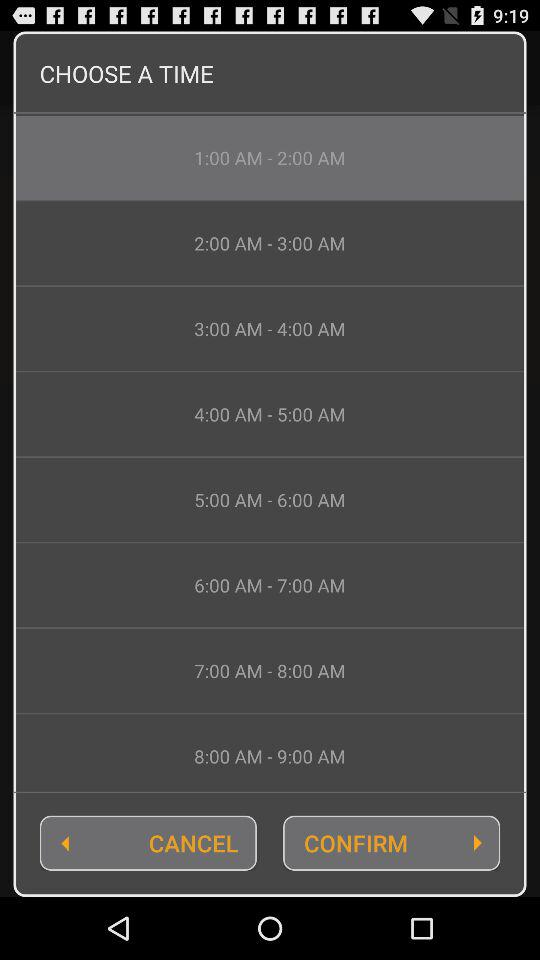How many hours are between the first and last time options?
Answer the question using a single word or phrase. 8 